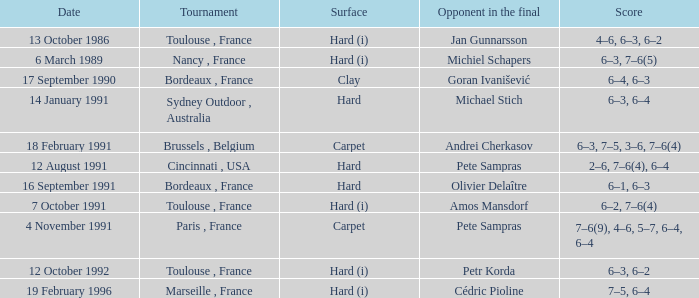What is the court type of the tournament featuring cédric pioline as the finalist? Hard (i). 